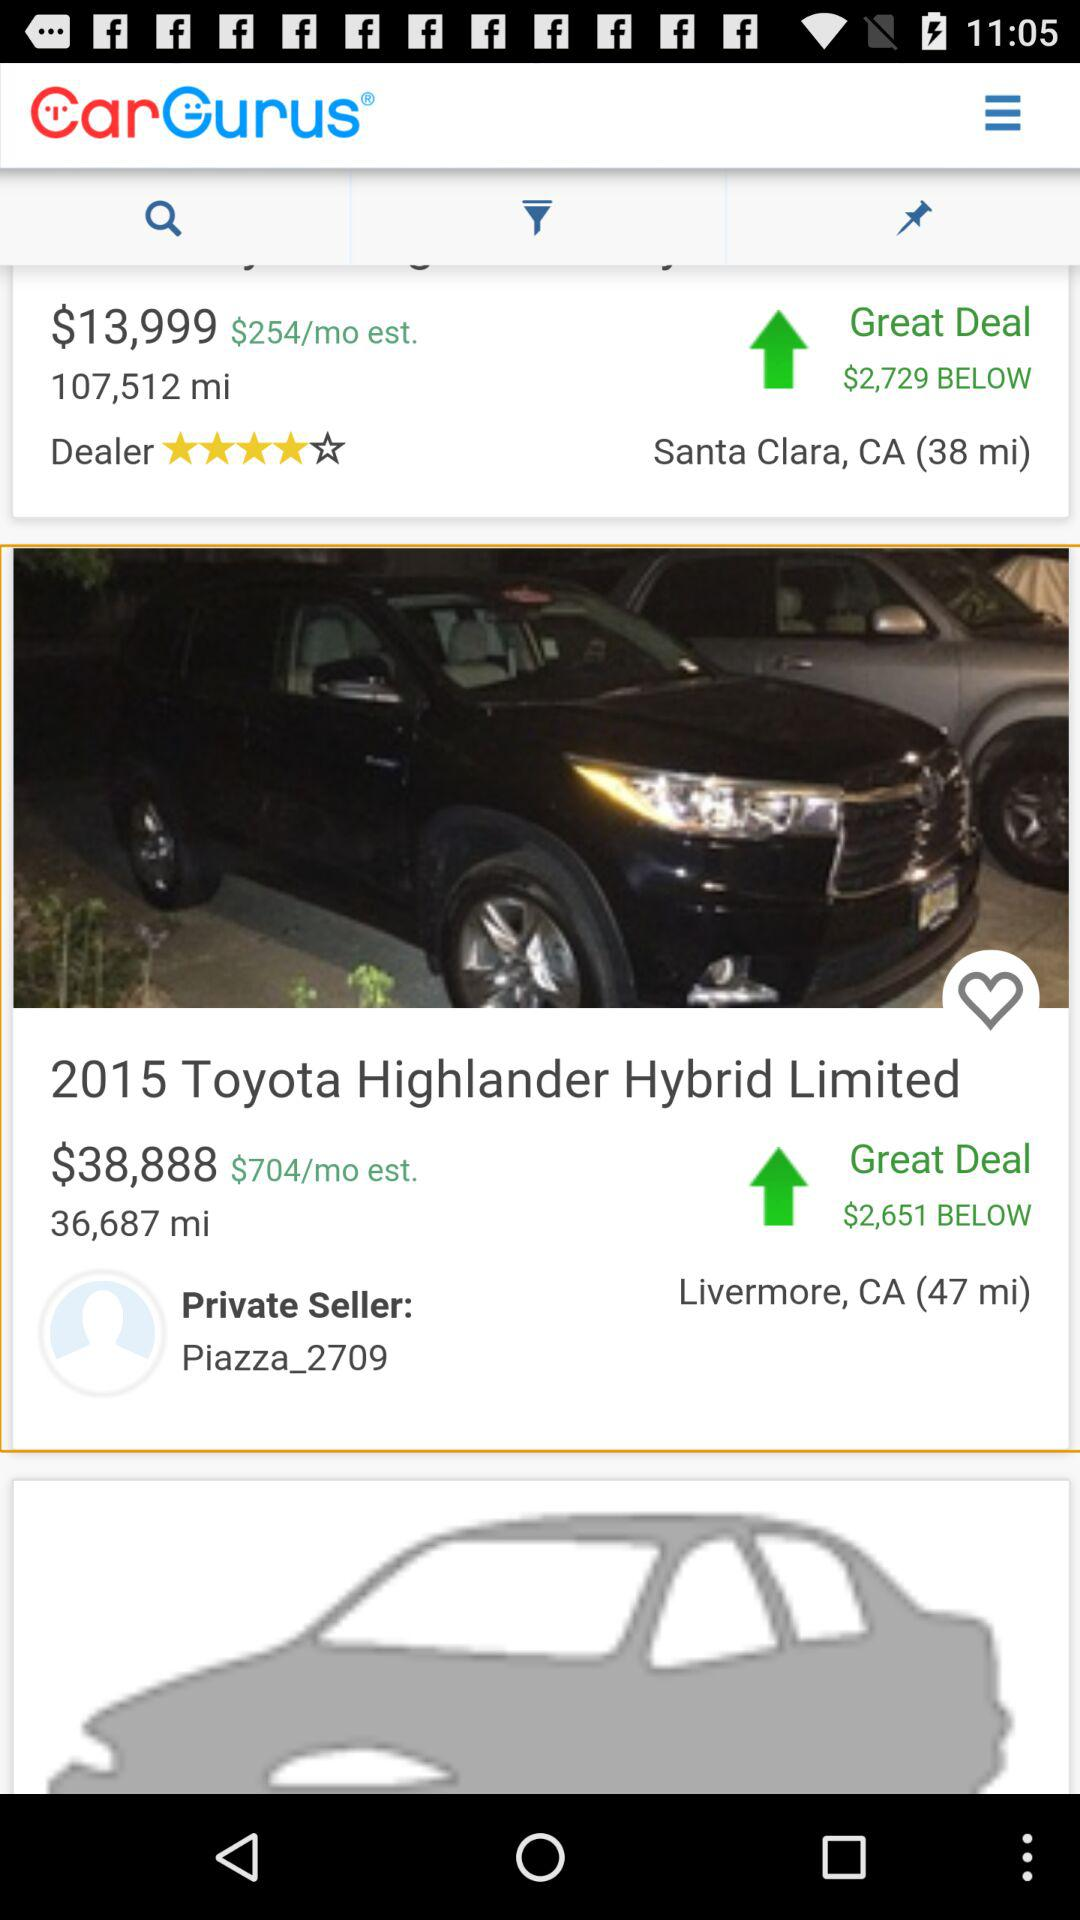What is the great deal for santa clara CA?
When the provided information is insufficient, respond with <no answer>. <no answer> 